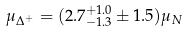<formula> <loc_0><loc_0><loc_500><loc_500>\mu _ { \Delta ^ { + } } = ( 2 . 7 ^ { + 1 . 0 } _ { - 1 . 3 } \pm 1 . 5 ) \mu _ { N }</formula> 